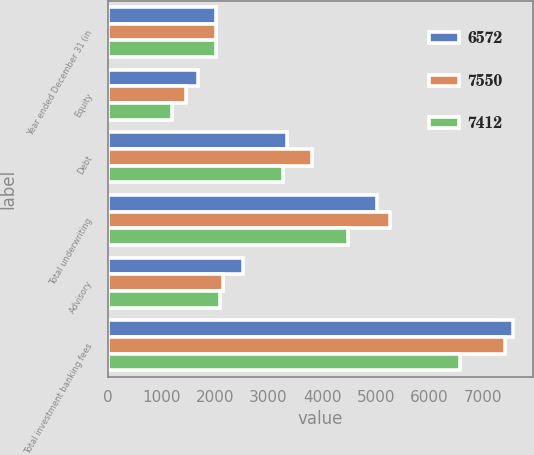Convert chart. <chart><loc_0><loc_0><loc_500><loc_500><stacked_bar_chart><ecel><fcel>Year ended December 31 (in<fcel>Equity<fcel>Debt<fcel>Total underwriting<fcel>Advisory<fcel>Total investment banking fees<nl><fcel>6572<fcel>2018<fcel>1684<fcel>3347<fcel>5031<fcel>2519<fcel>7550<nl><fcel>7550<fcel>2017<fcel>1466<fcel>3802<fcel>5268<fcel>2144<fcel>7412<nl><fcel>7412<fcel>2016<fcel>1200<fcel>3277<fcel>4477<fcel>2095<fcel>6572<nl></chart> 